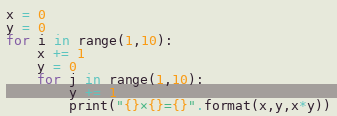<code> <loc_0><loc_0><loc_500><loc_500><_Python_>x = 0
y = 0
for i in range(1,10):
    x += 1
    y = 0
    for j in range(1,10):
        y += 1
        print("{}×{}={}".format(x,y,x*y))
</code> 